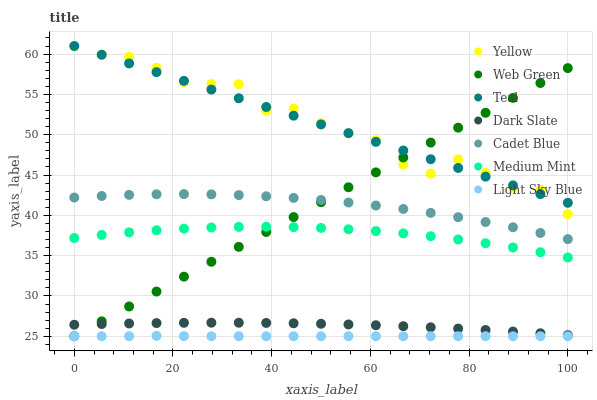Does Light Sky Blue have the minimum area under the curve?
Answer yes or no. Yes. Does Yellow have the maximum area under the curve?
Answer yes or no. Yes. Does Cadet Blue have the minimum area under the curve?
Answer yes or no. No. Does Cadet Blue have the maximum area under the curve?
Answer yes or no. No. Is Web Green the smoothest?
Answer yes or no. Yes. Is Yellow the roughest?
Answer yes or no. Yes. Is Cadet Blue the smoothest?
Answer yes or no. No. Is Cadet Blue the roughest?
Answer yes or no. No. Does Web Green have the lowest value?
Answer yes or no. Yes. Does Cadet Blue have the lowest value?
Answer yes or no. No. Does Teal have the highest value?
Answer yes or no. Yes. Does Cadet Blue have the highest value?
Answer yes or no. No. Is Light Sky Blue less than Teal?
Answer yes or no. Yes. Is Teal greater than Cadet Blue?
Answer yes or no. Yes. Does Web Green intersect Dark Slate?
Answer yes or no. Yes. Is Web Green less than Dark Slate?
Answer yes or no. No. Is Web Green greater than Dark Slate?
Answer yes or no. No. Does Light Sky Blue intersect Teal?
Answer yes or no. No. 